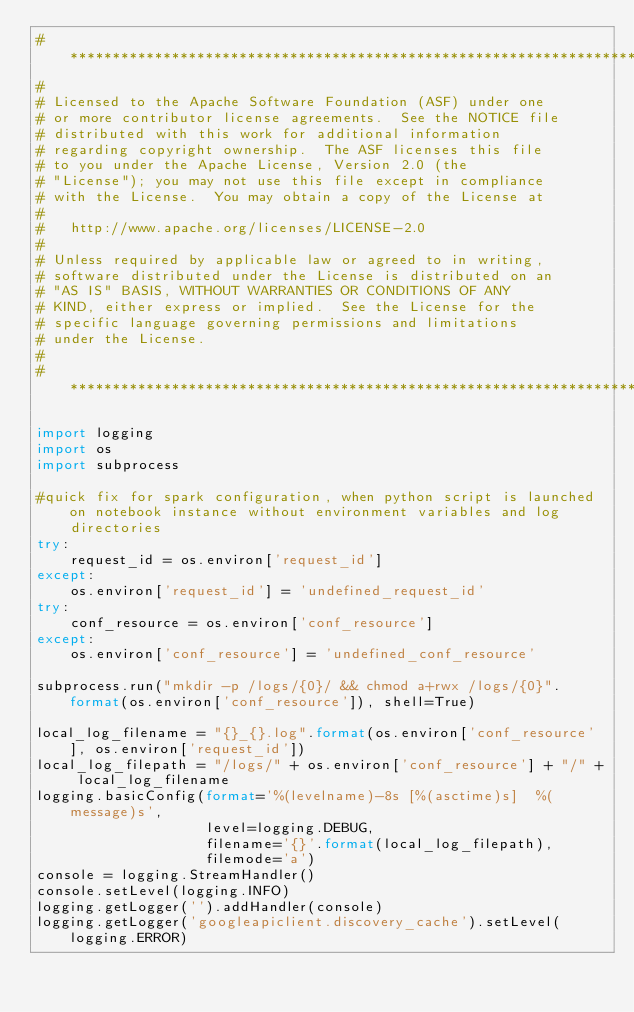Convert code to text. <code><loc_0><loc_0><loc_500><loc_500><_Python_># *****************************************************************************
#
# Licensed to the Apache Software Foundation (ASF) under one
# or more contributor license agreements.  See the NOTICE file
# distributed with this work for additional information
# regarding copyright ownership.  The ASF licenses this file
# to you under the Apache License, Version 2.0 (the
# "License"); you may not use this file except in compliance
# with the License.  You may obtain a copy of the License at
#
#   http://www.apache.org/licenses/LICENSE-2.0
#
# Unless required by applicable law or agreed to in writing,
# software distributed under the License is distributed on an
# "AS IS" BASIS, WITHOUT WARRANTIES OR CONDITIONS OF ANY
# KIND, either express or implied.  See the License for the
# specific language governing permissions and limitations
# under the License.
#
# ******************************************************************************

import logging
import os
import subprocess

#quick fix for spark configuration, when python script is launched on notebook instance without environment variables and log directories
try:
    request_id = os.environ['request_id']
except:
    os.environ['request_id'] = 'undefined_request_id'
try:
    conf_resource = os.environ['conf_resource']
except:
    os.environ['conf_resource'] = 'undefined_conf_resource'

subprocess.run("mkdir -p /logs/{0}/ && chmod a+rwx /logs/{0}".format(os.environ['conf_resource']), shell=True)

local_log_filename = "{}_{}.log".format(os.environ['conf_resource'], os.environ['request_id'])
local_log_filepath = "/logs/" + os.environ['conf_resource'] + "/" + local_log_filename
logging.basicConfig(format='%(levelname)-8s [%(asctime)s]  %(message)s',
                    level=logging.DEBUG,
                    filename='{}'.format(local_log_filepath),
                    filemode='a')
console = logging.StreamHandler()
console.setLevel(logging.INFO)
logging.getLogger('').addHandler(console)
logging.getLogger('googleapiclient.discovery_cache').setLevel(logging.ERROR)</code> 